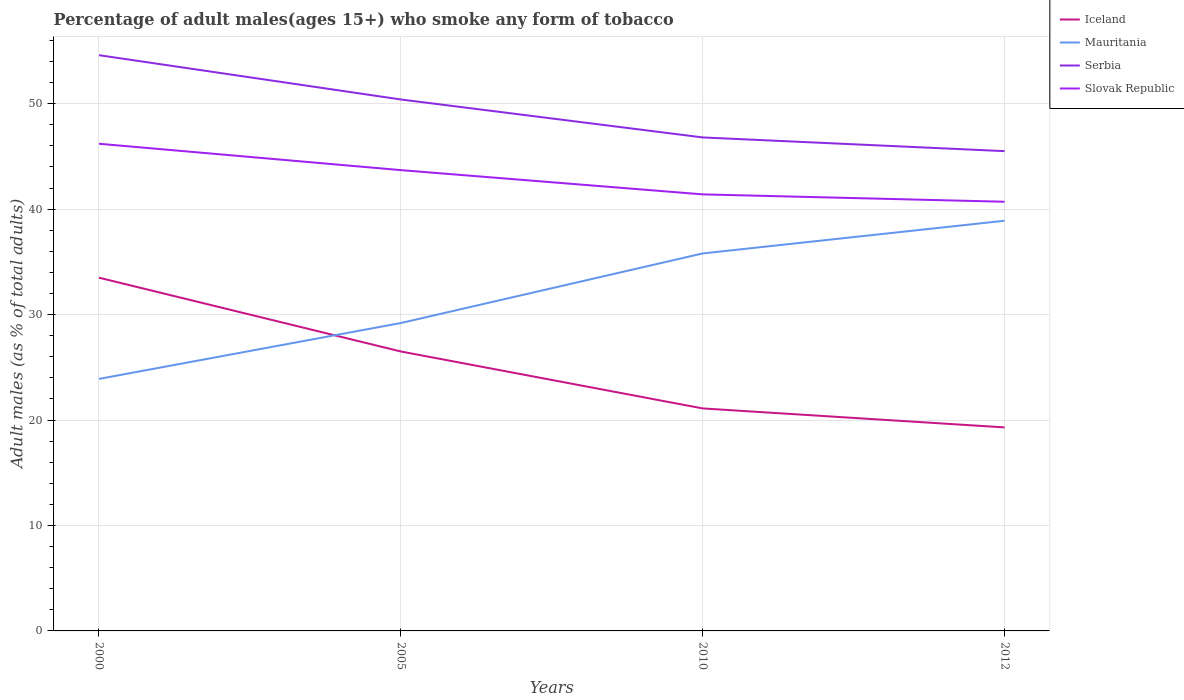How many different coloured lines are there?
Give a very brief answer. 4. Is the number of lines equal to the number of legend labels?
Keep it short and to the point. Yes. Across all years, what is the maximum percentage of adult males who smoke in Slovak Republic?
Offer a very short reply. 40.7. What is the total percentage of adult males who smoke in Iceland in the graph?
Your answer should be compact. 12.4. What is the difference between the highest and the second highest percentage of adult males who smoke in Mauritania?
Provide a succinct answer. 15. What is the difference between the highest and the lowest percentage of adult males who smoke in Serbia?
Provide a succinct answer. 2. Is the percentage of adult males who smoke in Iceland strictly greater than the percentage of adult males who smoke in Serbia over the years?
Your answer should be compact. Yes. Are the values on the major ticks of Y-axis written in scientific E-notation?
Give a very brief answer. No. Where does the legend appear in the graph?
Your response must be concise. Top right. How many legend labels are there?
Offer a very short reply. 4. How are the legend labels stacked?
Ensure brevity in your answer.  Vertical. What is the title of the graph?
Your answer should be very brief. Percentage of adult males(ages 15+) who smoke any form of tobacco. Does "South Asia" appear as one of the legend labels in the graph?
Provide a succinct answer. No. What is the label or title of the Y-axis?
Offer a very short reply. Adult males (as % of total adults). What is the Adult males (as % of total adults) of Iceland in 2000?
Offer a terse response. 33.5. What is the Adult males (as % of total adults) in Mauritania in 2000?
Provide a succinct answer. 23.9. What is the Adult males (as % of total adults) of Serbia in 2000?
Keep it short and to the point. 54.6. What is the Adult males (as % of total adults) of Slovak Republic in 2000?
Offer a very short reply. 46.2. What is the Adult males (as % of total adults) of Iceland in 2005?
Give a very brief answer. 26.5. What is the Adult males (as % of total adults) in Mauritania in 2005?
Keep it short and to the point. 29.2. What is the Adult males (as % of total adults) of Serbia in 2005?
Keep it short and to the point. 50.4. What is the Adult males (as % of total adults) in Slovak Republic in 2005?
Ensure brevity in your answer.  43.7. What is the Adult males (as % of total adults) in Iceland in 2010?
Your answer should be very brief. 21.1. What is the Adult males (as % of total adults) in Mauritania in 2010?
Your response must be concise. 35.8. What is the Adult males (as % of total adults) in Serbia in 2010?
Provide a short and direct response. 46.8. What is the Adult males (as % of total adults) in Slovak Republic in 2010?
Offer a very short reply. 41.4. What is the Adult males (as % of total adults) in Iceland in 2012?
Your answer should be very brief. 19.3. What is the Adult males (as % of total adults) of Mauritania in 2012?
Make the answer very short. 38.9. What is the Adult males (as % of total adults) in Serbia in 2012?
Make the answer very short. 45.5. What is the Adult males (as % of total adults) in Slovak Republic in 2012?
Your answer should be compact. 40.7. Across all years, what is the maximum Adult males (as % of total adults) of Iceland?
Make the answer very short. 33.5. Across all years, what is the maximum Adult males (as % of total adults) in Mauritania?
Ensure brevity in your answer.  38.9. Across all years, what is the maximum Adult males (as % of total adults) in Serbia?
Provide a succinct answer. 54.6. Across all years, what is the maximum Adult males (as % of total adults) in Slovak Republic?
Your answer should be very brief. 46.2. Across all years, what is the minimum Adult males (as % of total adults) in Iceland?
Your response must be concise. 19.3. Across all years, what is the minimum Adult males (as % of total adults) of Mauritania?
Provide a succinct answer. 23.9. Across all years, what is the minimum Adult males (as % of total adults) in Serbia?
Provide a succinct answer. 45.5. Across all years, what is the minimum Adult males (as % of total adults) of Slovak Republic?
Provide a succinct answer. 40.7. What is the total Adult males (as % of total adults) of Iceland in the graph?
Provide a succinct answer. 100.4. What is the total Adult males (as % of total adults) in Mauritania in the graph?
Your response must be concise. 127.8. What is the total Adult males (as % of total adults) in Serbia in the graph?
Your answer should be compact. 197.3. What is the total Adult males (as % of total adults) in Slovak Republic in the graph?
Your answer should be compact. 172. What is the difference between the Adult males (as % of total adults) in Serbia in 2000 and that in 2005?
Your answer should be very brief. 4.2. What is the difference between the Adult males (as % of total adults) in Slovak Republic in 2000 and that in 2005?
Your answer should be very brief. 2.5. What is the difference between the Adult males (as % of total adults) in Serbia in 2000 and that in 2010?
Make the answer very short. 7.8. What is the difference between the Adult males (as % of total adults) in Iceland in 2000 and that in 2012?
Make the answer very short. 14.2. What is the difference between the Adult males (as % of total adults) in Mauritania in 2000 and that in 2012?
Your answer should be very brief. -15. What is the difference between the Adult males (as % of total adults) of Slovak Republic in 2000 and that in 2012?
Your answer should be compact. 5.5. What is the difference between the Adult males (as % of total adults) in Iceland in 2005 and that in 2010?
Provide a succinct answer. 5.4. What is the difference between the Adult males (as % of total adults) in Mauritania in 2005 and that in 2010?
Your response must be concise. -6.6. What is the difference between the Adult males (as % of total adults) of Slovak Republic in 2005 and that in 2010?
Offer a terse response. 2.3. What is the difference between the Adult males (as % of total adults) in Iceland in 2005 and that in 2012?
Your answer should be compact. 7.2. What is the difference between the Adult males (as % of total adults) of Mauritania in 2005 and that in 2012?
Give a very brief answer. -9.7. What is the difference between the Adult males (as % of total adults) in Slovak Republic in 2005 and that in 2012?
Give a very brief answer. 3. What is the difference between the Adult males (as % of total adults) in Iceland in 2010 and that in 2012?
Make the answer very short. 1.8. What is the difference between the Adult males (as % of total adults) in Mauritania in 2010 and that in 2012?
Provide a short and direct response. -3.1. What is the difference between the Adult males (as % of total adults) of Serbia in 2010 and that in 2012?
Your answer should be very brief. 1.3. What is the difference between the Adult males (as % of total adults) in Iceland in 2000 and the Adult males (as % of total adults) in Serbia in 2005?
Provide a short and direct response. -16.9. What is the difference between the Adult males (as % of total adults) of Iceland in 2000 and the Adult males (as % of total adults) of Slovak Republic in 2005?
Your answer should be compact. -10.2. What is the difference between the Adult males (as % of total adults) of Mauritania in 2000 and the Adult males (as % of total adults) of Serbia in 2005?
Make the answer very short. -26.5. What is the difference between the Adult males (as % of total adults) in Mauritania in 2000 and the Adult males (as % of total adults) in Slovak Republic in 2005?
Provide a short and direct response. -19.8. What is the difference between the Adult males (as % of total adults) of Mauritania in 2000 and the Adult males (as % of total adults) of Serbia in 2010?
Provide a short and direct response. -22.9. What is the difference between the Adult males (as % of total adults) of Mauritania in 2000 and the Adult males (as % of total adults) of Slovak Republic in 2010?
Make the answer very short. -17.5. What is the difference between the Adult males (as % of total adults) in Iceland in 2000 and the Adult males (as % of total adults) in Serbia in 2012?
Offer a terse response. -12. What is the difference between the Adult males (as % of total adults) in Iceland in 2000 and the Adult males (as % of total adults) in Slovak Republic in 2012?
Give a very brief answer. -7.2. What is the difference between the Adult males (as % of total adults) of Mauritania in 2000 and the Adult males (as % of total adults) of Serbia in 2012?
Offer a very short reply. -21.6. What is the difference between the Adult males (as % of total adults) in Mauritania in 2000 and the Adult males (as % of total adults) in Slovak Republic in 2012?
Offer a terse response. -16.8. What is the difference between the Adult males (as % of total adults) of Iceland in 2005 and the Adult males (as % of total adults) of Mauritania in 2010?
Offer a terse response. -9.3. What is the difference between the Adult males (as % of total adults) of Iceland in 2005 and the Adult males (as % of total adults) of Serbia in 2010?
Your response must be concise. -20.3. What is the difference between the Adult males (as % of total adults) of Iceland in 2005 and the Adult males (as % of total adults) of Slovak Republic in 2010?
Provide a succinct answer. -14.9. What is the difference between the Adult males (as % of total adults) of Mauritania in 2005 and the Adult males (as % of total adults) of Serbia in 2010?
Your answer should be compact. -17.6. What is the difference between the Adult males (as % of total adults) of Mauritania in 2005 and the Adult males (as % of total adults) of Slovak Republic in 2010?
Make the answer very short. -12.2. What is the difference between the Adult males (as % of total adults) in Iceland in 2005 and the Adult males (as % of total adults) in Mauritania in 2012?
Offer a terse response. -12.4. What is the difference between the Adult males (as % of total adults) in Iceland in 2005 and the Adult males (as % of total adults) in Serbia in 2012?
Offer a terse response. -19. What is the difference between the Adult males (as % of total adults) in Iceland in 2005 and the Adult males (as % of total adults) in Slovak Republic in 2012?
Your answer should be very brief. -14.2. What is the difference between the Adult males (as % of total adults) of Mauritania in 2005 and the Adult males (as % of total adults) of Serbia in 2012?
Ensure brevity in your answer.  -16.3. What is the difference between the Adult males (as % of total adults) of Mauritania in 2005 and the Adult males (as % of total adults) of Slovak Republic in 2012?
Ensure brevity in your answer.  -11.5. What is the difference between the Adult males (as % of total adults) in Serbia in 2005 and the Adult males (as % of total adults) in Slovak Republic in 2012?
Offer a very short reply. 9.7. What is the difference between the Adult males (as % of total adults) of Iceland in 2010 and the Adult males (as % of total adults) of Mauritania in 2012?
Make the answer very short. -17.8. What is the difference between the Adult males (as % of total adults) in Iceland in 2010 and the Adult males (as % of total adults) in Serbia in 2012?
Give a very brief answer. -24.4. What is the difference between the Adult males (as % of total adults) in Iceland in 2010 and the Adult males (as % of total adults) in Slovak Republic in 2012?
Keep it short and to the point. -19.6. What is the difference between the Adult males (as % of total adults) in Mauritania in 2010 and the Adult males (as % of total adults) in Serbia in 2012?
Your response must be concise. -9.7. What is the difference between the Adult males (as % of total adults) in Serbia in 2010 and the Adult males (as % of total adults) in Slovak Republic in 2012?
Provide a succinct answer. 6.1. What is the average Adult males (as % of total adults) in Iceland per year?
Offer a terse response. 25.1. What is the average Adult males (as % of total adults) of Mauritania per year?
Your response must be concise. 31.95. What is the average Adult males (as % of total adults) of Serbia per year?
Offer a terse response. 49.33. What is the average Adult males (as % of total adults) of Slovak Republic per year?
Provide a succinct answer. 43. In the year 2000, what is the difference between the Adult males (as % of total adults) in Iceland and Adult males (as % of total adults) in Serbia?
Provide a short and direct response. -21.1. In the year 2000, what is the difference between the Adult males (as % of total adults) in Mauritania and Adult males (as % of total adults) in Serbia?
Provide a short and direct response. -30.7. In the year 2000, what is the difference between the Adult males (as % of total adults) of Mauritania and Adult males (as % of total adults) of Slovak Republic?
Make the answer very short. -22.3. In the year 2000, what is the difference between the Adult males (as % of total adults) in Serbia and Adult males (as % of total adults) in Slovak Republic?
Make the answer very short. 8.4. In the year 2005, what is the difference between the Adult males (as % of total adults) in Iceland and Adult males (as % of total adults) in Mauritania?
Keep it short and to the point. -2.7. In the year 2005, what is the difference between the Adult males (as % of total adults) of Iceland and Adult males (as % of total adults) of Serbia?
Give a very brief answer. -23.9. In the year 2005, what is the difference between the Adult males (as % of total adults) of Iceland and Adult males (as % of total adults) of Slovak Republic?
Make the answer very short. -17.2. In the year 2005, what is the difference between the Adult males (as % of total adults) of Mauritania and Adult males (as % of total adults) of Serbia?
Provide a succinct answer. -21.2. In the year 2005, what is the difference between the Adult males (as % of total adults) of Serbia and Adult males (as % of total adults) of Slovak Republic?
Make the answer very short. 6.7. In the year 2010, what is the difference between the Adult males (as % of total adults) of Iceland and Adult males (as % of total adults) of Mauritania?
Offer a terse response. -14.7. In the year 2010, what is the difference between the Adult males (as % of total adults) of Iceland and Adult males (as % of total adults) of Serbia?
Provide a succinct answer. -25.7. In the year 2010, what is the difference between the Adult males (as % of total adults) of Iceland and Adult males (as % of total adults) of Slovak Republic?
Provide a succinct answer. -20.3. In the year 2010, what is the difference between the Adult males (as % of total adults) in Mauritania and Adult males (as % of total adults) in Serbia?
Give a very brief answer. -11. In the year 2012, what is the difference between the Adult males (as % of total adults) in Iceland and Adult males (as % of total adults) in Mauritania?
Provide a short and direct response. -19.6. In the year 2012, what is the difference between the Adult males (as % of total adults) of Iceland and Adult males (as % of total adults) of Serbia?
Provide a short and direct response. -26.2. In the year 2012, what is the difference between the Adult males (as % of total adults) of Iceland and Adult males (as % of total adults) of Slovak Republic?
Keep it short and to the point. -21.4. In the year 2012, what is the difference between the Adult males (as % of total adults) of Mauritania and Adult males (as % of total adults) of Slovak Republic?
Give a very brief answer. -1.8. In the year 2012, what is the difference between the Adult males (as % of total adults) of Serbia and Adult males (as % of total adults) of Slovak Republic?
Offer a terse response. 4.8. What is the ratio of the Adult males (as % of total adults) of Iceland in 2000 to that in 2005?
Your answer should be compact. 1.26. What is the ratio of the Adult males (as % of total adults) in Mauritania in 2000 to that in 2005?
Keep it short and to the point. 0.82. What is the ratio of the Adult males (as % of total adults) of Slovak Republic in 2000 to that in 2005?
Offer a very short reply. 1.06. What is the ratio of the Adult males (as % of total adults) of Iceland in 2000 to that in 2010?
Your answer should be very brief. 1.59. What is the ratio of the Adult males (as % of total adults) in Mauritania in 2000 to that in 2010?
Give a very brief answer. 0.67. What is the ratio of the Adult males (as % of total adults) in Serbia in 2000 to that in 2010?
Ensure brevity in your answer.  1.17. What is the ratio of the Adult males (as % of total adults) of Slovak Republic in 2000 to that in 2010?
Keep it short and to the point. 1.12. What is the ratio of the Adult males (as % of total adults) of Iceland in 2000 to that in 2012?
Your answer should be compact. 1.74. What is the ratio of the Adult males (as % of total adults) of Mauritania in 2000 to that in 2012?
Your answer should be compact. 0.61. What is the ratio of the Adult males (as % of total adults) of Slovak Republic in 2000 to that in 2012?
Your answer should be compact. 1.14. What is the ratio of the Adult males (as % of total adults) in Iceland in 2005 to that in 2010?
Make the answer very short. 1.26. What is the ratio of the Adult males (as % of total adults) in Mauritania in 2005 to that in 2010?
Provide a short and direct response. 0.82. What is the ratio of the Adult males (as % of total adults) in Serbia in 2005 to that in 2010?
Your answer should be very brief. 1.08. What is the ratio of the Adult males (as % of total adults) in Slovak Republic in 2005 to that in 2010?
Provide a succinct answer. 1.06. What is the ratio of the Adult males (as % of total adults) in Iceland in 2005 to that in 2012?
Your response must be concise. 1.37. What is the ratio of the Adult males (as % of total adults) of Mauritania in 2005 to that in 2012?
Your response must be concise. 0.75. What is the ratio of the Adult males (as % of total adults) of Serbia in 2005 to that in 2012?
Make the answer very short. 1.11. What is the ratio of the Adult males (as % of total adults) of Slovak Republic in 2005 to that in 2012?
Provide a succinct answer. 1.07. What is the ratio of the Adult males (as % of total adults) in Iceland in 2010 to that in 2012?
Your answer should be compact. 1.09. What is the ratio of the Adult males (as % of total adults) of Mauritania in 2010 to that in 2012?
Your answer should be compact. 0.92. What is the ratio of the Adult males (as % of total adults) in Serbia in 2010 to that in 2012?
Offer a terse response. 1.03. What is the ratio of the Adult males (as % of total adults) in Slovak Republic in 2010 to that in 2012?
Ensure brevity in your answer.  1.02. What is the difference between the highest and the second highest Adult males (as % of total adults) in Iceland?
Keep it short and to the point. 7. What is the difference between the highest and the second highest Adult males (as % of total adults) in Mauritania?
Ensure brevity in your answer.  3.1. What is the difference between the highest and the second highest Adult males (as % of total adults) in Serbia?
Your answer should be very brief. 4.2. What is the difference between the highest and the lowest Adult males (as % of total adults) in Mauritania?
Your response must be concise. 15. 